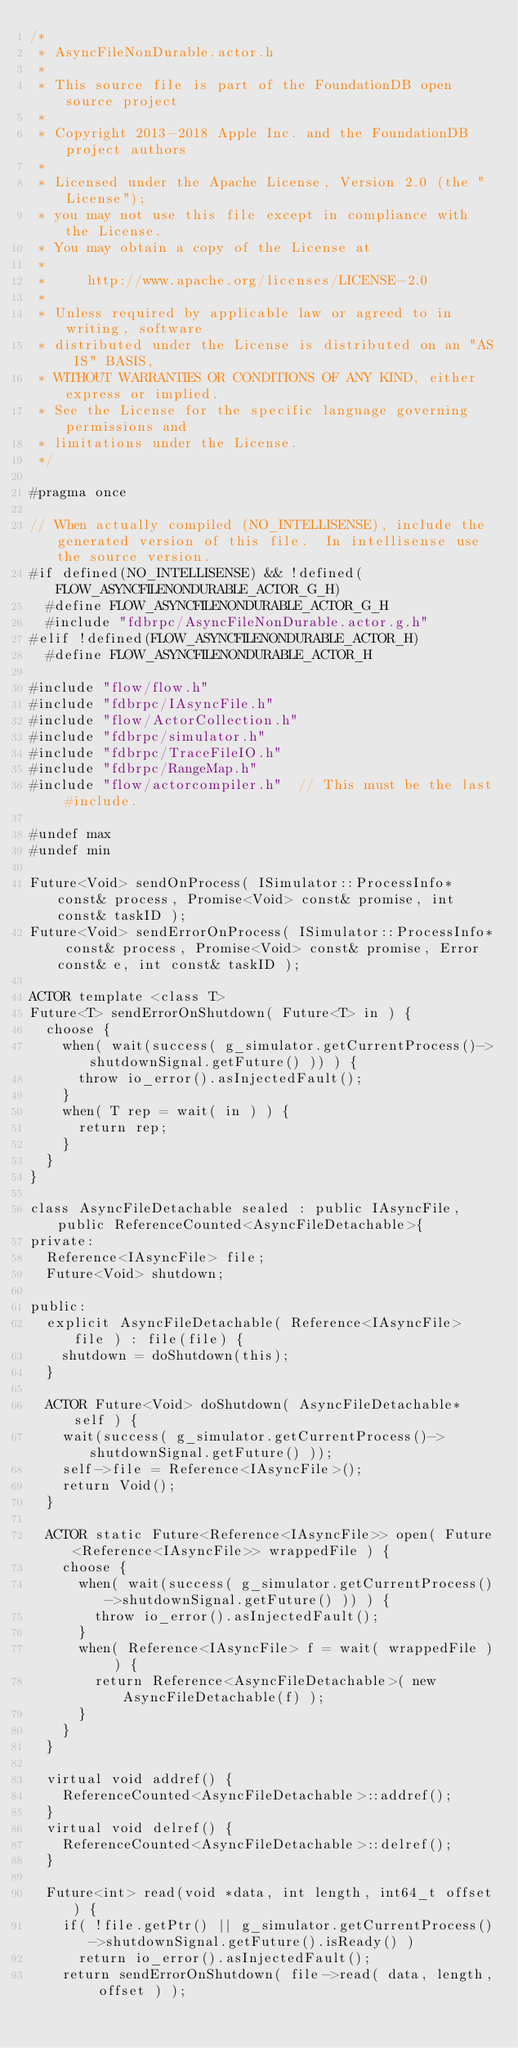<code> <loc_0><loc_0><loc_500><loc_500><_C_>/*
 * AsyncFileNonDurable.actor.h
 *
 * This source file is part of the FoundationDB open source project
 *
 * Copyright 2013-2018 Apple Inc. and the FoundationDB project authors
 *
 * Licensed under the Apache License, Version 2.0 (the "License");
 * you may not use this file except in compliance with the License.
 * You may obtain a copy of the License at
 *
 *     http://www.apache.org/licenses/LICENSE-2.0
 *
 * Unless required by applicable law or agreed to in writing, software
 * distributed under the License is distributed on an "AS IS" BASIS,
 * WITHOUT WARRANTIES OR CONDITIONS OF ANY KIND, either express or implied.
 * See the License for the specific language governing permissions and
 * limitations under the License.
 */

#pragma once

// When actually compiled (NO_INTELLISENSE), include the generated version of this file.  In intellisense use the source version.
#if defined(NO_INTELLISENSE) && !defined(FLOW_ASYNCFILENONDURABLE_ACTOR_G_H)
	#define FLOW_ASYNCFILENONDURABLE_ACTOR_G_H
	#include "fdbrpc/AsyncFileNonDurable.actor.g.h"
#elif !defined(FLOW_ASYNCFILENONDURABLE_ACTOR_H)
	#define FLOW_ASYNCFILENONDURABLE_ACTOR_H

#include "flow/flow.h"
#include "fdbrpc/IAsyncFile.h"
#include "flow/ActorCollection.h"
#include "fdbrpc/simulator.h"
#include "fdbrpc/TraceFileIO.h"
#include "fdbrpc/RangeMap.h"
#include "flow/actorcompiler.h"  // This must be the last #include.

#undef max
#undef min

Future<Void> sendOnProcess( ISimulator::ProcessInfo* const& process, Promise<Void> const& promise, int const& taskID );
Future<Void> sendErrorOnProcess( ISimulator::ProcessInfo* const& process, Promise<Void> const& promise, Error const& e, int const& taskID );

ACTOR template <class T> 
Future<T> sendErrorOnShutdown( Future<T> in ) {
	choose {
		when( wait(success( g_simulator.getCurrentProcess()->shutdownSignal.getFuture() )) ) {
			throw io_error().asInjectedFault();
		}
		when( T rep = wait( in ) ) {
			return rep;
		}
	}
}

class AsyncFileDetachable sealed : public IAsyncFile, public ReferenceCounted<AsyncFileDetachable>{
private:
	Reference<IAsyncFile> file;
	Future<Void> shutdown;

public:
	explicit AsyncFileDetachable( Reference<IAsyncFile> file ) : file(file) {
		shutdown = doShutdown(this);
	}

	ACTOR Future<Void> doShutdown( AsyncFileDetachable* self ) {
		wait(success( g_simulator.getCurrentProcess()->shutdownSignal.getFuture() ));
		self->file = Reference<IAsyncFile>();
		return Void();
	}
	
	ACTOR static Future<Reference<IAsyncFile>> open( Future<Reference<IAsyncFile>> wrappedFile ) {
		choose {
			when( wait(success( g_simulator.getCurrentProcess()->shutdownSignal.getFuture() )) ) {
				throw io_error().asInjectedFault();
			}
			when( Reference<IAsyncFile> f = wait( wrappedFile ) ) {
				return Reference<AsyncFileDetachable>( new AsyncFileDetachable(f) );
			}
		}
	}

	virtual void addref() {
		ReferenceCounted<AsyncFileDetachable>::addref();
	}
	virtual void delref() {
		ReferenceCounted<AsyncFileDetachable>::delref();
	}

	Future<int> read(void *data, int length, int64_t offset) {
		if( !file.getPtr() || g_simulator.getCurrentProcess()->shutdownSignal.getFuture().isReady() )
			return io_error().asInjectedFault();
		return sendErrorOnShutdown( file->read( data, length, offset ) );</code> 